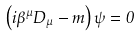Convert formula to latex. <formula><loc_0><loc_0><loc_500><loc_500>\left ( i \beta ^ { \mu } D _ { \mu } - m \right ) \psi = 0</formula> 